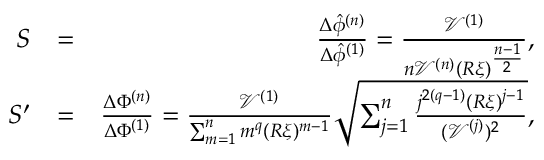<formula> <loc_0><loc_0><loc_500><loc_500>\begin{array} { r l r } { S } & { = } & { \frac { \Delta \hat { \phi } ^ { ( n ) } } { \Delta \hat { \phi } ^ { ( 1 ) } } = \frac { \mathcal { V } ^ { ( 1 ) } } { n \mathcal { V } ^ { ( n ) } ( R \xi ) ^ { \frac { n - 1 } { 2 } } } , } \\ { S ^ { \prime } } & { = } & { \frac { \Delta \Phi ^ { ( n ) } } { \Delta \Phi ^ { ( 1 ) } } = \frac { \mathcal { V } ^ { ( 1 ) } } { \sum _ { m = 1 } ^ { n } m ^ { q } ( R \xi ) ^ { m - 1 } } \sqrt { \sum _ { j = 1 } ^ { n } \frac { j ^ { 2 ( q - 1 ) } ( R \xi ) ^ { j - 1 } } { ( \mathcal { V } ^ { ( j ) } ) ^ { 2 } } } , } \end{array}</formula> 